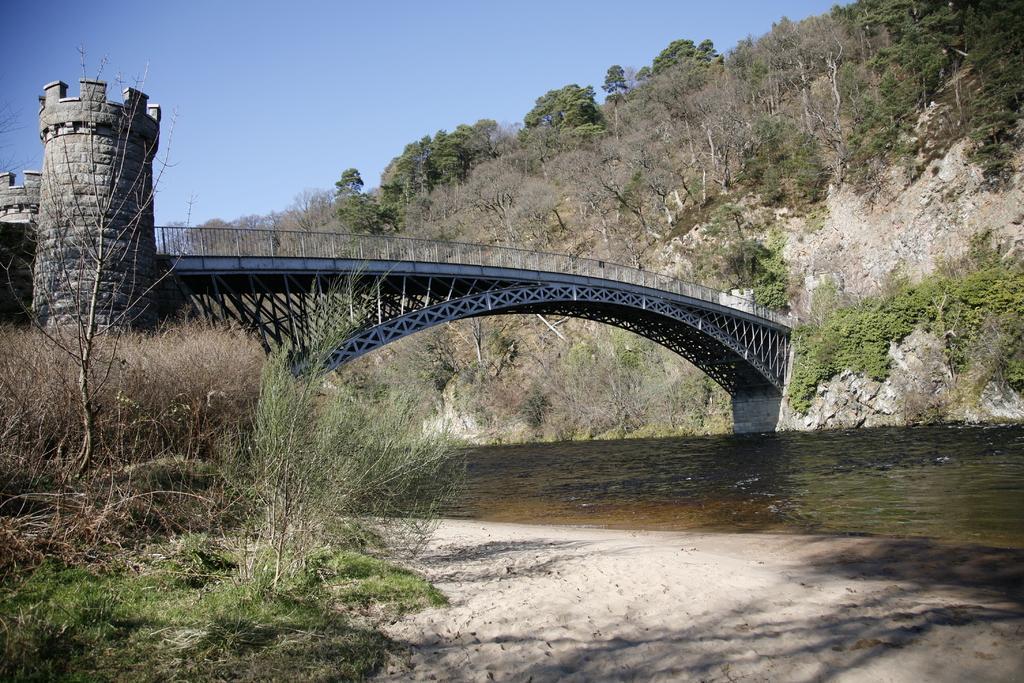In one or two sentences, can you explain what this image depicts? In the center of the image a bridge is there. On the right side of the image we can see hills, plants are there. At the top left corner grass is present. At the bottom of the image water is there. At the top of the image sky is there. At the bottom of the image soil is present. 